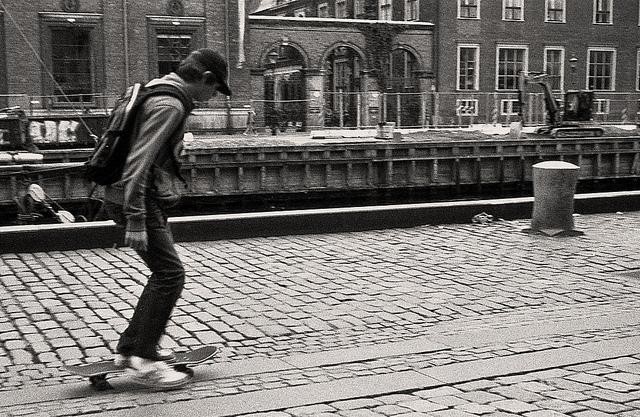Is this a black and white picture?
Answer briefly. Yes. What is the man doing?
Answer briefly. Skateboarding. On what kind of paving is the boy riding?
Keep it brief. Cobblestone. 